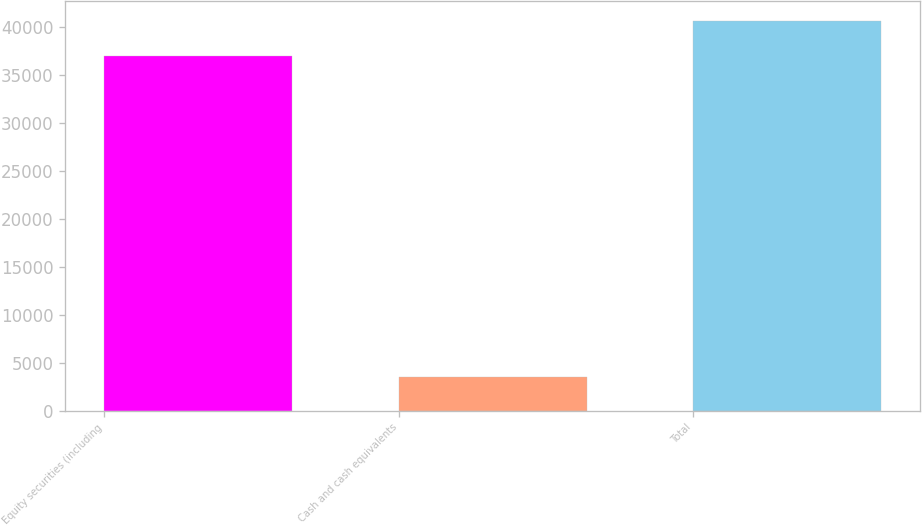Convert chart. <chart><loc_0><loc_0><loc_500><loc_500><bar_chart><fcel>Equity securities (including<fcel>Cash and cash equivalents<fcel>Total<nl><fcel>36970<fcel>3453<fcel>40667<nl></chart> 